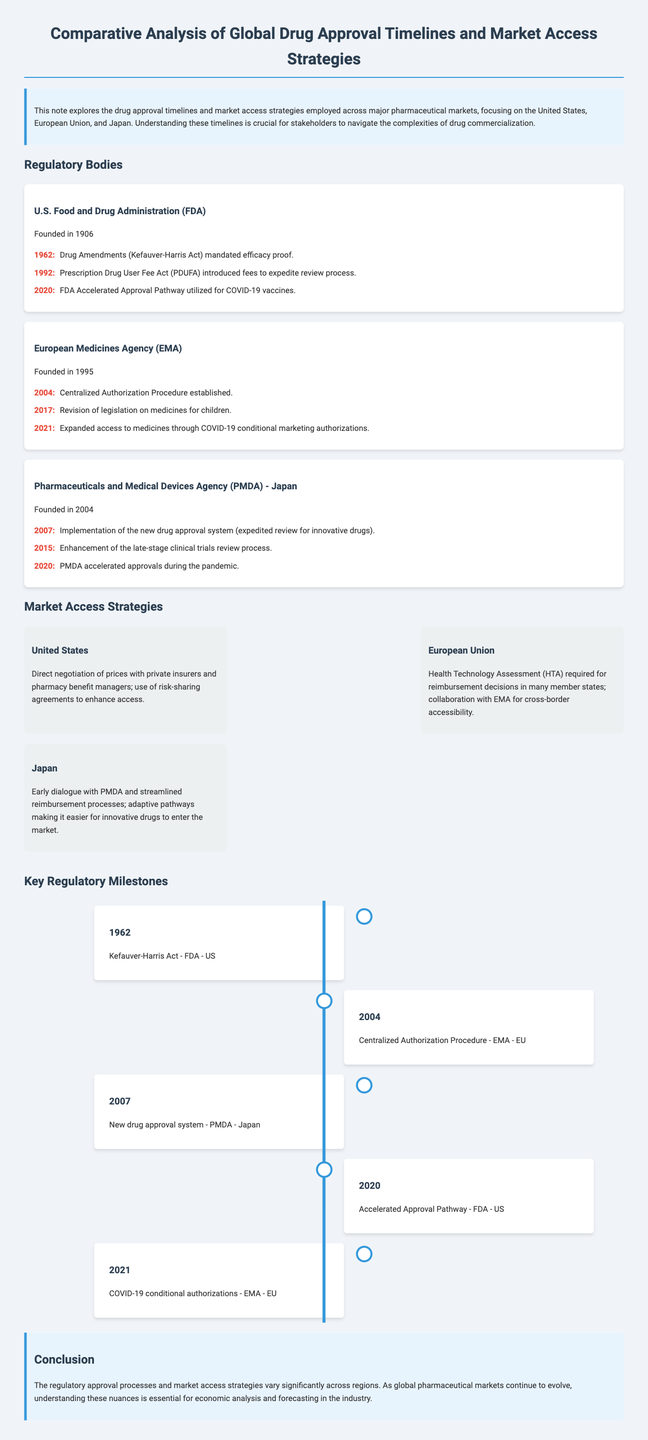What year was the U.S. Food and Drug Administration (FDA) founded? The FDA was founded in 1906, as stated in the regulatory body section.
Answer: 1906 What does PDUFA stand for? PDUFA is mentioned in relation to the Prescription Drug User Fee Act, which is described in the milestones of the FDA.
Answer: Prescription Drug User Fee Act What significant act was passed in 2004 for the EMA? The document states that the Centralized Authorization Procedure was established in 2004 for the EMA.
Answer: Centralized Authorization Procedure In what year did the PMDA - Japan implement a new drug approval system? The new drug approval system was implemented by the PMDA in 2007, as indicated in their regulatory milestones.
Answer: 2007 What is a market access strategy used in the United States? Direct negotiation with private insurers and use of risk-sharing agreements are strategies mentioned for the U.S. market access.
Answer: Direct negotiation How many key regulatory milestones are mentioned in the timeline? The timeline contains a total of five key regulatory milestones according to the number of items listed.
Answer: 5 Which regulatory body was established first among the three mentioned? The FDA was founded first in 1906, making it the earliest among the three regulatory bodies.
Answer: FDA What year saw the revision of legislation on medicines for children by the EMA? The revision of legislation on medicines for children by the EMA occurred in 2017 as stated in the milestones.
Answer: 2017 What access strategy does Japan utilize for pharmaceutical products? Japan employs early dialogue with PMDA and streamlined reimbursement processes as key market access strategies.
Answer: Early dialogue 